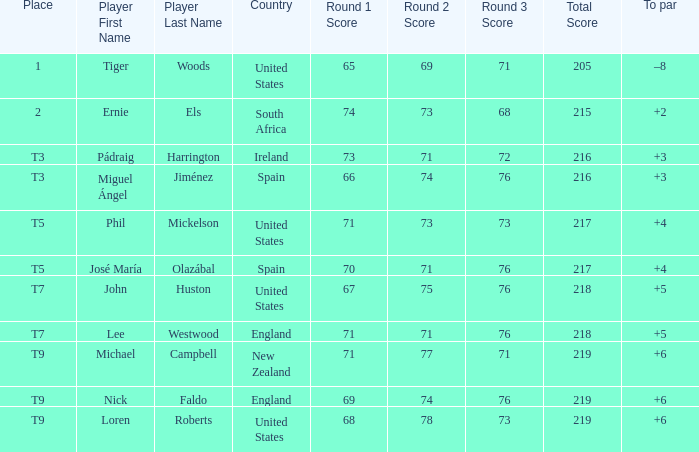What is Country, when Place is "T9", and when Player is "Michael Campbell"? New Zealand. Parse the table in full. {'header': ['Place', 'Player First Name', 'Player Last Name', 'Country', 'Round 1 Score', 'Round 2 Score', 'Round 3 Score', 'Total Score', 'To par'], 'rows': [['1', 'Tiger', 'Woods', 'United States', '65', '69', '71', '205', '–8'], ['2', 'Ernie', 'Els', 'South Africa', '74', '73', '68', '215', '+2'], ['T3', 'Pádraig', 'Harrington', 'Ireland', '73', '71', '72', '216', '+3'], ['T3', 'Miguel Ángel', 'Jiménez', 'Spain', '66', '74', '76', '216', '+3'], ['T5', 'Phil', 'Mickelson', 'United States', '71', '73', '73', '217', '+4'], ['T5', 'José María', 'Olazábal', 'Spain', '70', '71', '76', '217', '+4'], ['T7', 'John', 'Huston', 'United States', '67', '75', '76', '218', '+5'], ['T7', 'Lee', 'Westwood', 'England', '71', '71', '76', '218', '+5'], ['T9', 'Michael', 'Campbell', 'New Zealand', '71', '77', '71', '219', '+6'], ['T9', 'Nick', 'Faldo', 'England', '69', '74', '76', '219', '+6'], ['T9', 'Loren', 'Roberts', 'United States', '68', '78', '73', '219', '+6']]} 